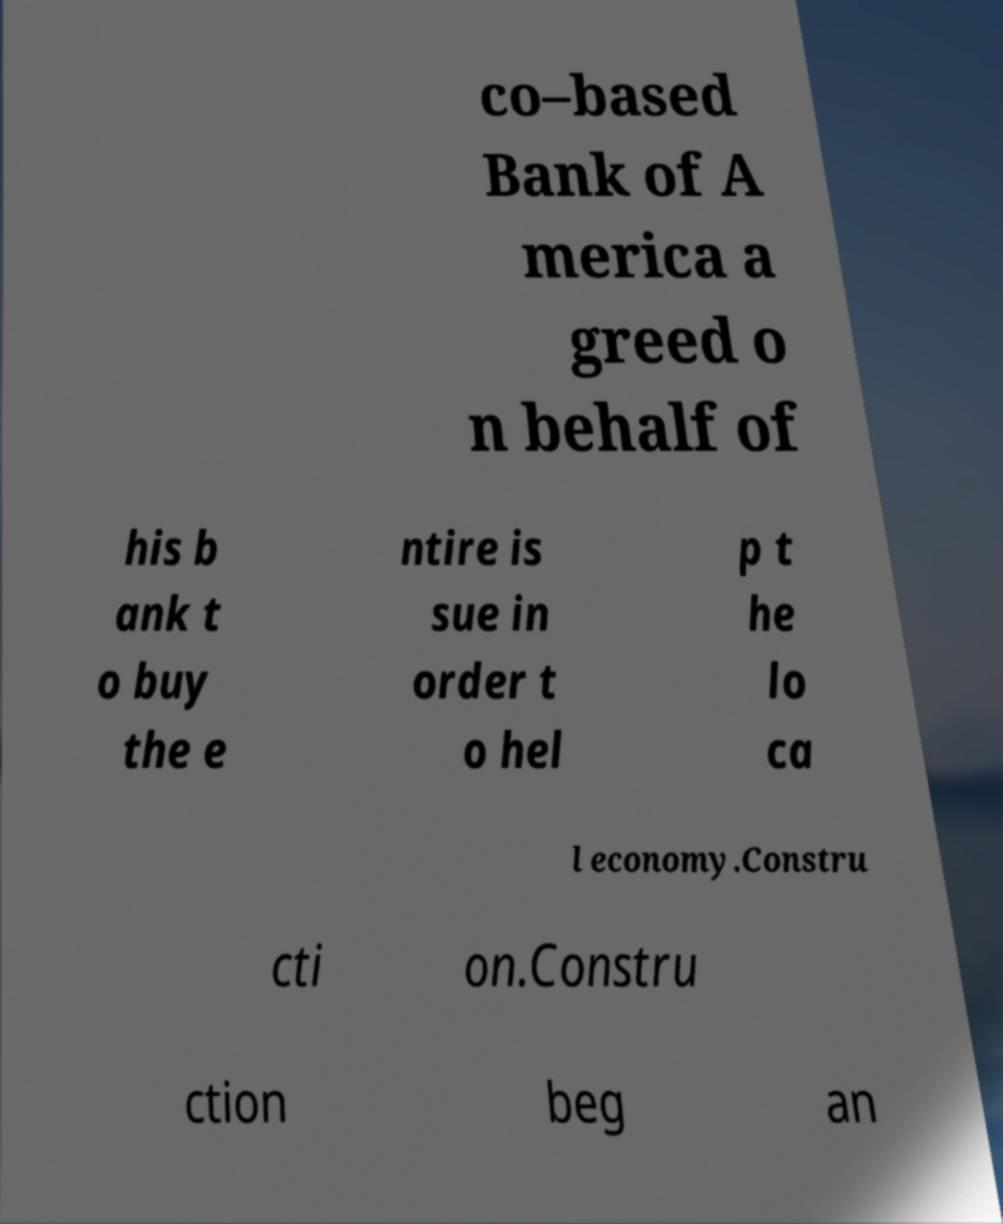Could you extract and type out the text from this image? co–based Bank of A merica a greed o n behalf of his b ank t o buy the e ntire is sue in order t o hel p t he lo ca l economy.Constru cti on.Constru ction beg an 